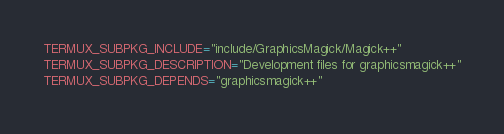<code> <loc_0><loc_0><loc_500><loc_500><_Bash_>TERMUX_SUBPKG_INCLUDE="include/GraphicsMagick/Magick++"
TERMUX_SUBPKG_DESCRIPTION="Development files for graphicsmagick++"
TERMUX_SUBPKG_DEPENDS="graphicsmagick++"
</code> 